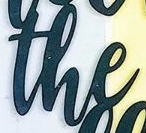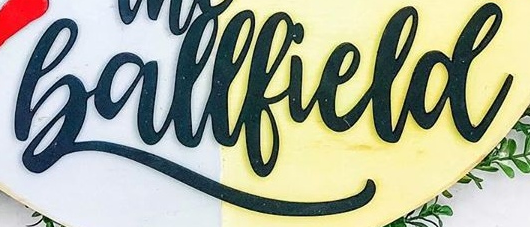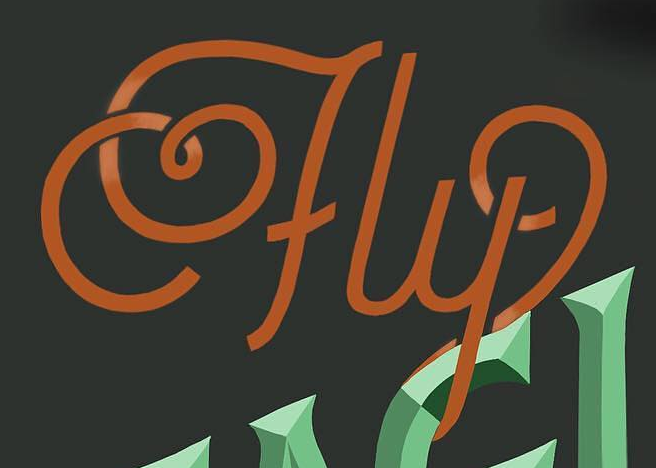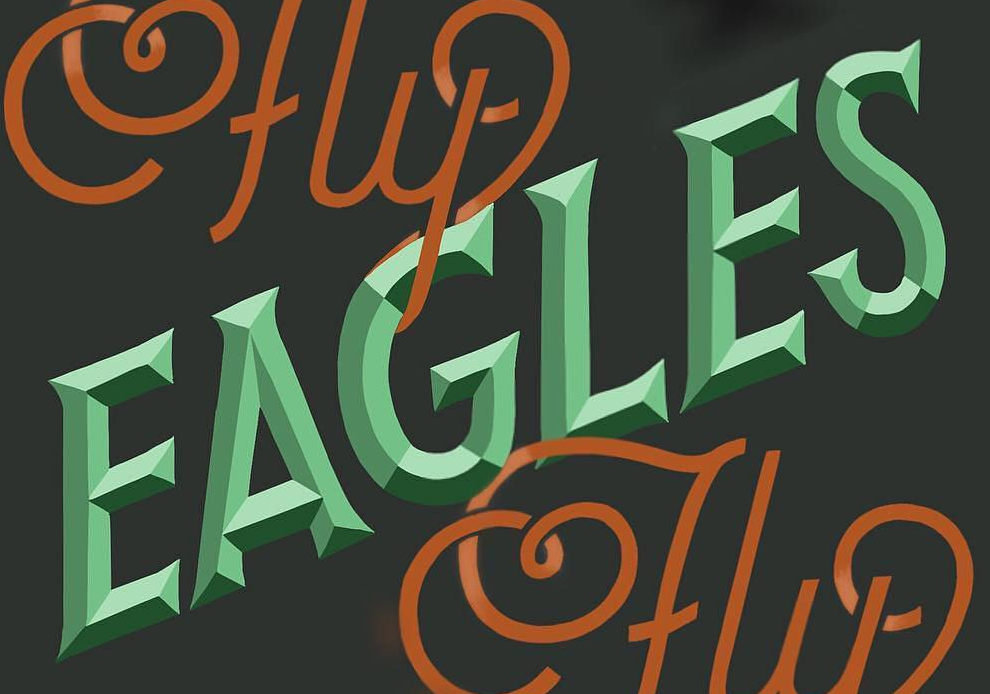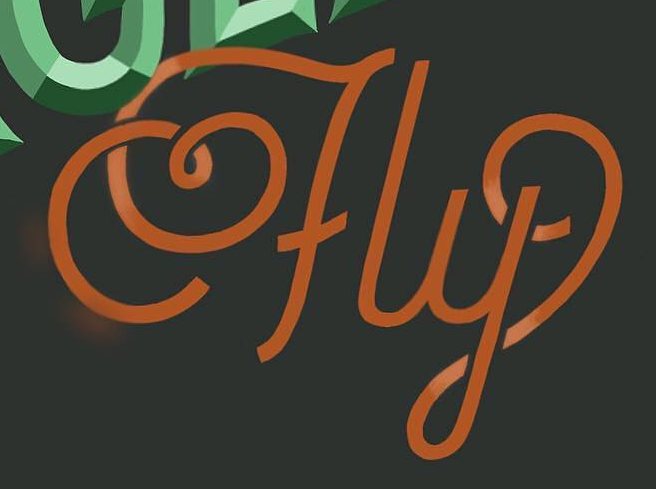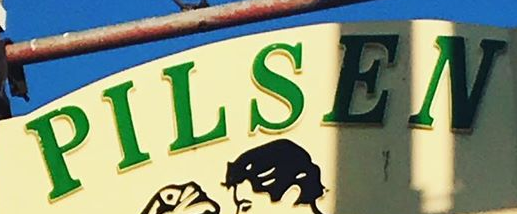Transcribe the words shown in these images in order, separated by a semicolon. the; Ballfield; fly; EAGLES; fly; PILSEN 